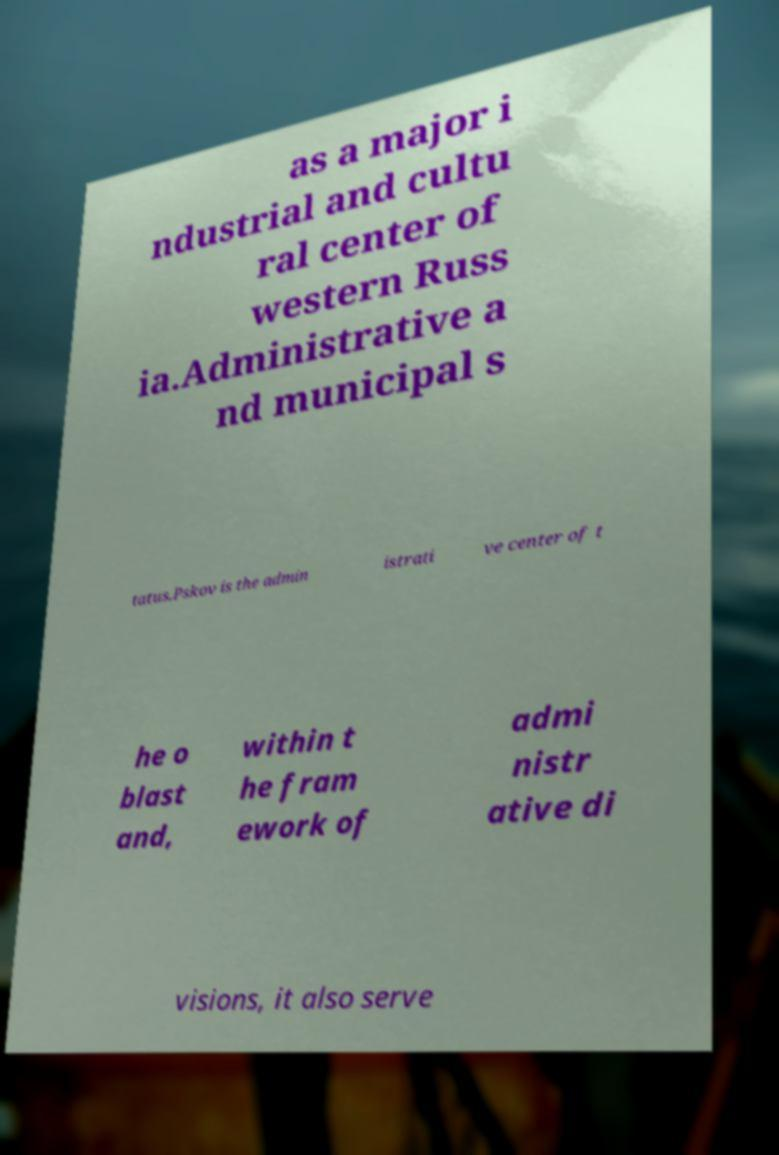Please read and relay the text visible in this image. What does it say? as a major i ndustrial and cultu ral center of western Russ ia.Administrative a nd municipal s tatus.Pskov is the admin istrati ve center of t he o blast and, within t he fram ework of admi nistr ative di visions, it also serve 